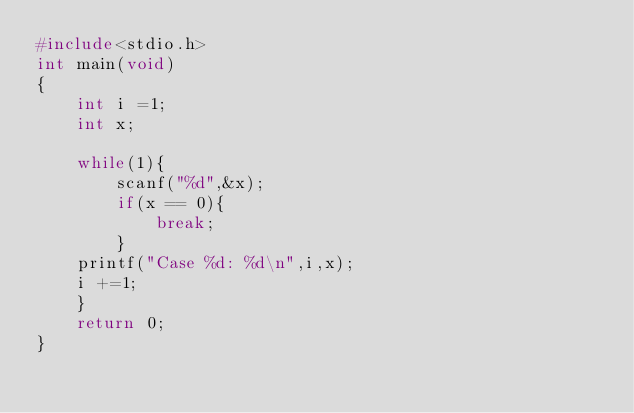<code> <loc_0><loc_0><loc_500><loc_500><_C_>#include<stdio.h>
int main(void)
{
	int i =1;
	int x;
	
	while(1){
		scanf("%d",&x);
		if(x == 0){
			break;
		}
	printf("Case %d: %d\n",i,x);
	i +=1;
	}
	return 0;
}</code> 